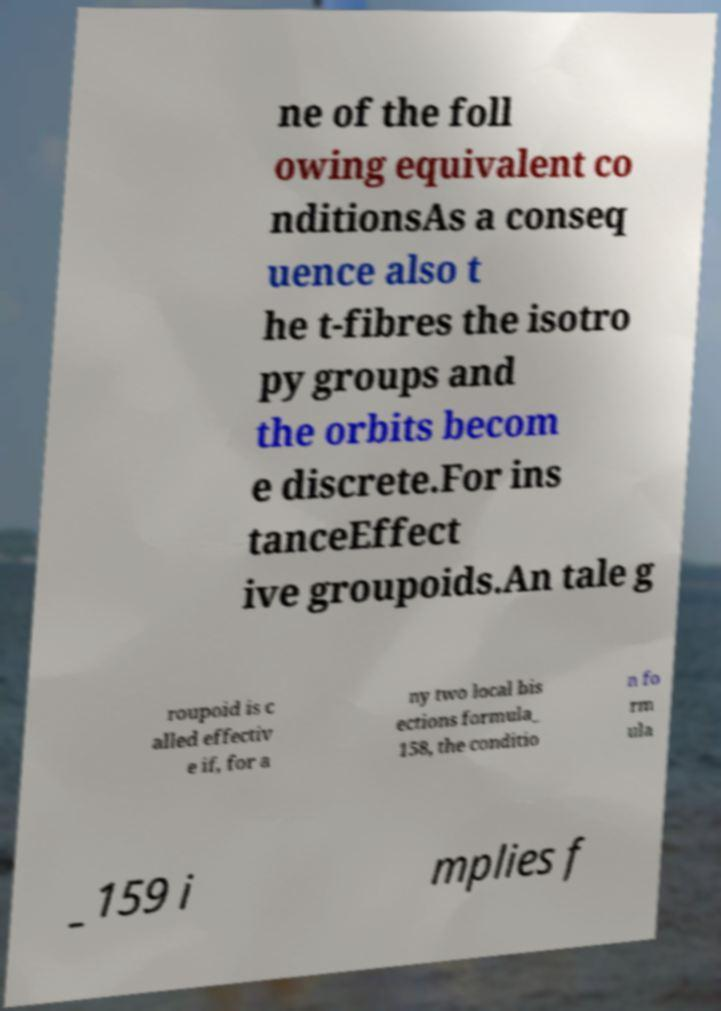What messages or text are displayed in this image? I need them in a readable, typed format. ne of the foll owing equivalent co nditionsAs a conseq uence also t he t-fibres the isotro py groups and the orbits becom e discrete.For ins tanceEffect ive groupoids.An tale g roupoid is c alled effectiv e if, for a ny two local bis ections formula_ 158, the conditio n fo rm ula _159 i mplies f 